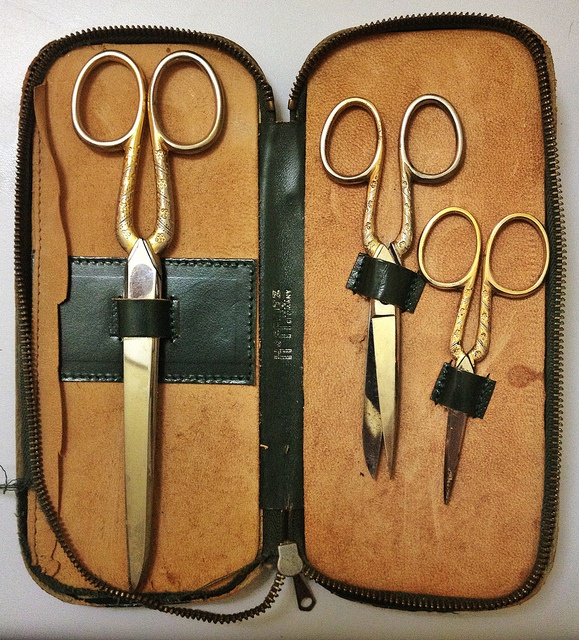Describe the objects in this image and their specific colors. I can see scissors in lightgray, maroon, tan, and olive tones, scissors in lightgray, tan, maroon, brown, and khaki tones, and scissors in lightgray, tan, brown, black, and maroon tones in this image. 